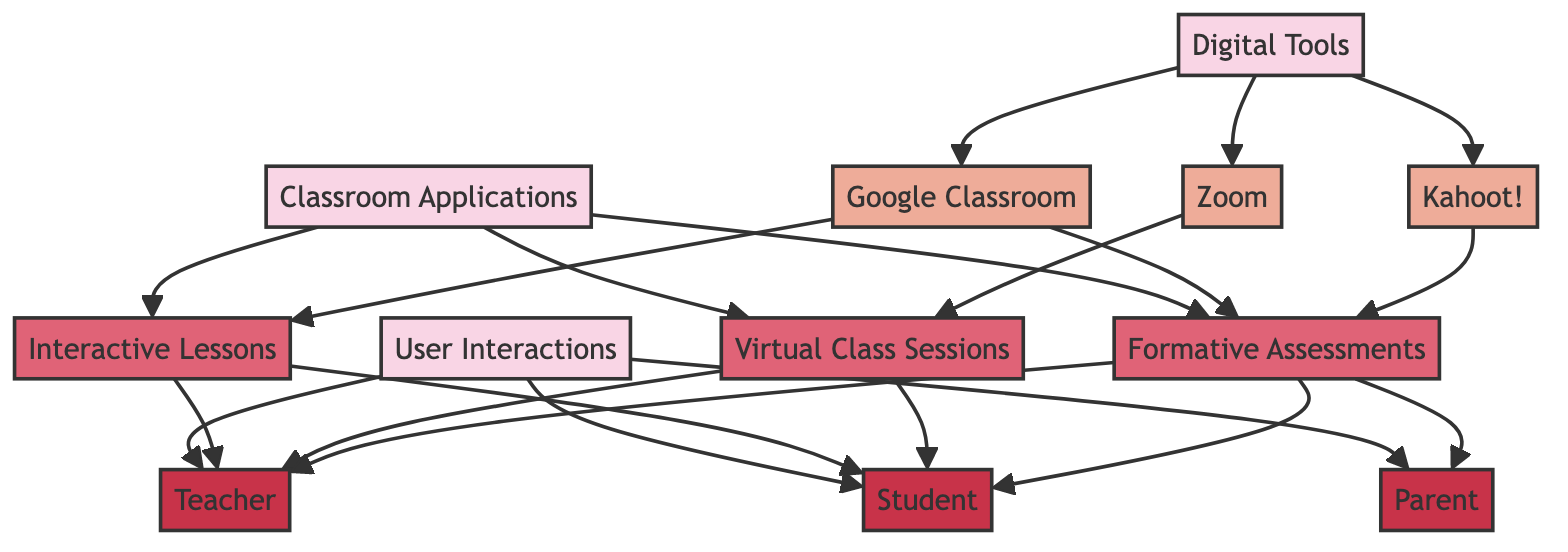What are the categories present in the diagram? The diagram contains three categories: Digital Tools, Classroom Applications, and User Interactions. These categories are clearly indicated as higher-level nodes that group the specific tools, applications, and user types listed below them.
Answer: Digital Tools, Classroom Applications, User Interactions How many digital tools are represented in the diagram? The diagram lists three specific digital tools: Google Classroom, Zoom, and Kahoot! Therefore, by counting these nodes, we find that there are three digital tools represented.
Answer: 3 Which application is connected to Google Classroom? Google Classroom has edges connecting it to the applications Interactive Lessons and Formative Assessments. By checking the relationships, Interactive Lessons and Formative Assessments are both linked directly to Google Classroom. However, if we focus on the first application, the answer is Interactive Lessons.
Answer: Interactive Lessons How many user types are shown in the diagram? The diagram identifies three user types: Teacher, Student, and Parent. Each of these is represented as a separate user node, adding up to a total of three users.
Answer: 3 What type of application is linked to Zoom? Zoom is connected to the Virtual Class Sessions application. This connection is established through an edge drawn from the Zoom node to the Virtual Class Sessions node in the diagram, indicating a direct relationship.
Answer: Virtual Class Sessions Which user interacts with Formative Assessments? The Formative Assessments application is connected to three types of users: Teacher, Student, and Parent. Each user is represented by an edge leading from the Formative Assessments node to each user node, showing that all three users engage with this application.
Answer: Teacher, Student, Parent Which digital tool is linked to the most classroom applications? By inspecting the edges, Google Classroom connects to two classroom applications: Interactive Lessons and Formative Assessments. Zoom connects to one application, Virtual Class Sessions, and Kahoot! is linked to one application, Formative Assessments. Therefore, Google Classroom has the most connections to classroom applications.
Answer: Google Classroom How many edges are in the diagram? The edges represent the connections between nodes. By counting them in the data provided, there are a total of 17 edges. This enumeration reflects the various relationships between digital tools, applications, and users shown in the diagram.
Answer: 17 Which digital tool connects to the most user types? By analyzing the edges, Google Classroom and Kahoot! connect to the Teacher and Student user types, while Zoom connects to the Teacher and Student as well. Each of these digital tools links to the same two user types. However, all three user types interact with the Formative Assessments application via Kahoot!. Thus, Kahoot! connects to the most unique user types.
Answer: Kahoot! 